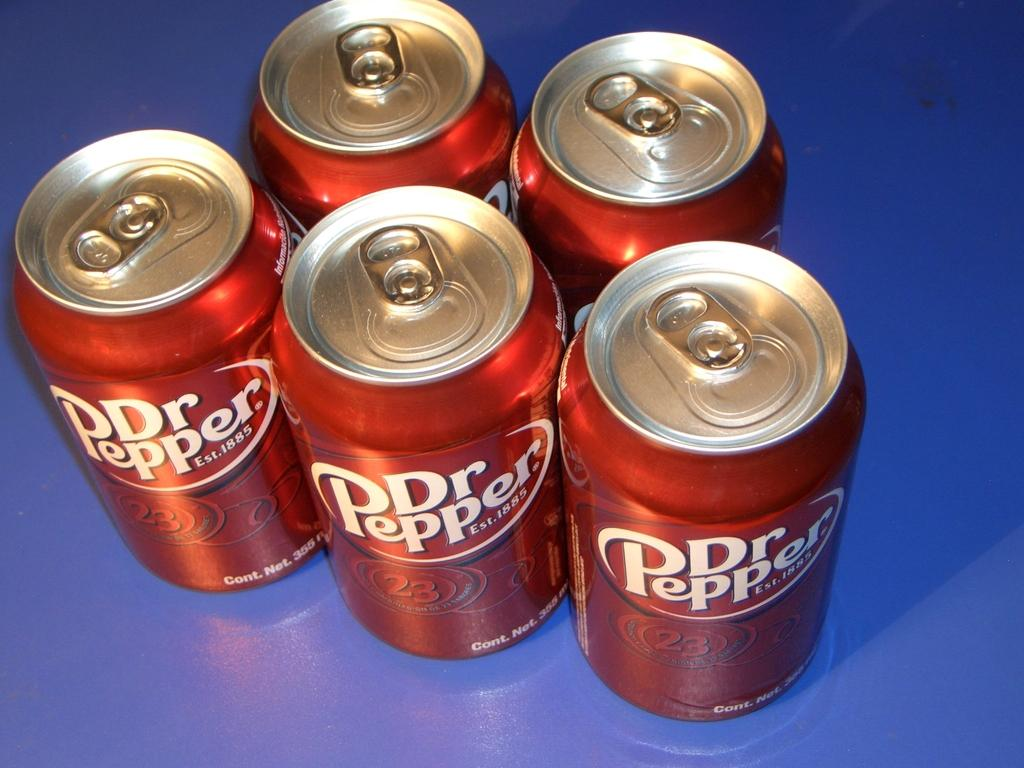<image>
Give a short and clear explanation of the subsequent image. a Dr. Pepper next to many other cans as well 